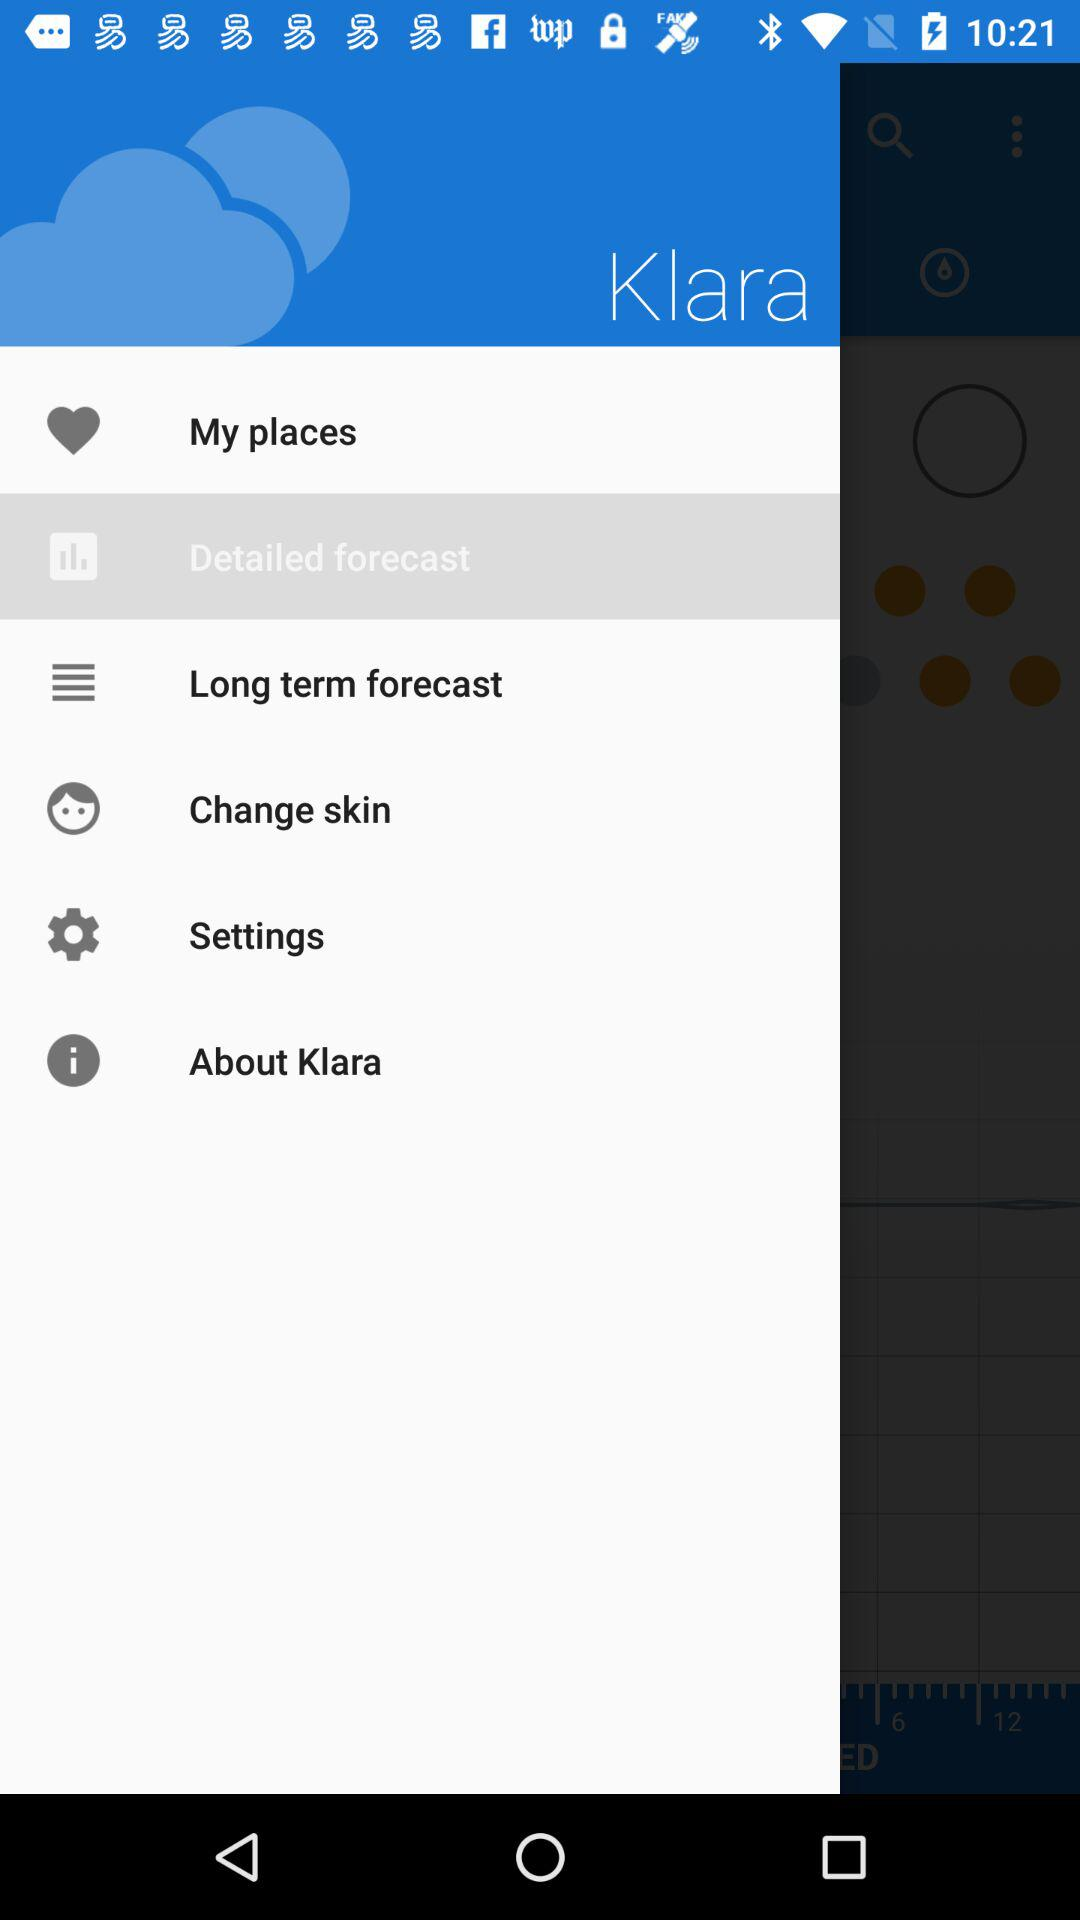Which item is selected in the menu? The selected item is "Detailed forecast". 